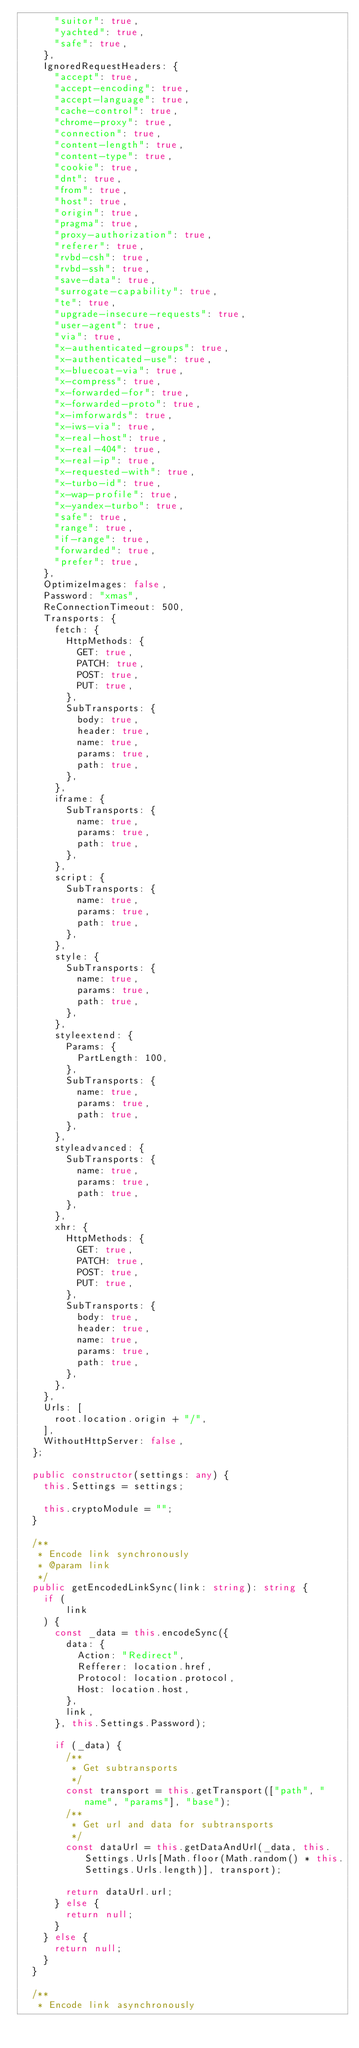Convert code to text. <code><loc_0><loc_0><loc_500><loc_500><_TypeScript_>      "suitor": true,
      "yachted": true,
      "safe": true,
    },
    IgnoredRequestHeaders: {
      "accept": true,
      "accept-encoding": true,
      "accept-language": true,
      "cache-control": true,
      "chrome-proxy": true,
      "connection": true,
      "content-length": true,
      "content-type": true,
      "cookie": true,
      "dnt": true,
      "from": true,
      "host": true,
      "origin": true,
      "pragma": true,
      "proxy-authorization": true,
      "referer": true,
      "rvbd-csh": true,
      "rvbd-ssh": true,
      "save-data": true,
      "surrogate-capability": true,
      "te": true,
      "upgrade-insecure-requests": true,
      "user-agent": true,
      "via": true,
      "x-authenticated-groups": true,
      "x-authenticated-use": true,
      "x-bluecoat-via": true,
      "x-compress": true,
      "x-forwarded-for": true,
      "x-forwarded-proto": true,
      "x-imforwards": true,
      "x-iws-via": true,
      "x-real-host": true,
      "x-real-404": true,
      "x-real-ip": true,
      "x-requested-with": true,
      "x-turbo-id": true,
      "x-wap-profile": true,
      "x-yandex-turbo": true,
      "safe": true,
      "range": true,
      "if-range": true,
      "forwarded": true,
      "prefer": true,
    },
    OptimizeImages: false,
    Password: "xmas",
    ReConnectionTimeout: 500,
    Transports: {
      fetch: {
        HttpMethods: {
          GET: true,
          PATCH: true,
          POST: true,
          PUT: true,
        },
        SubTransports: {
          body: true,
          header: true,
          name: true,
          params: true,
          path: true,
        },
      },
      iframe: {
        SubTransports: {
          name: true,
          params: true,
          path: true,
        },
      },
      script: {
        SubTransports: {
          name: true,
          params: true,
          path: true,
        },
      },
      style: {
        SubTransports: {
          name: true,
          params: true,
          path: true,
        },
      },
      styleextend: {
        Params: {
          PartLength: 100,
        },
        SubTransports: {
          name: true,
          params: true,
          path: true,
        },
      },
      styleadvanced: {
        SubTransports: {
          name: true,
          params: true,
          path: true,
        },
      },
      xhr: {
        HttpMethods: {
          GET: true,
          PATCH: true,
          POST: true,
          PUT: true,
        },
        SubTransports: {
          body: true,
          header: true,
          name: true,
          params: true,
          path: true,
        },
      },
    },
    Urls: [
      root.location.origin + "/",
    ],
    WithoutHttpServer: false,
  };

  public constructor(settings: any) {
    this.Settings = settings;

    this.cryptoModule = "";
  }

  /**
   * Encode link synchronously
   * @param link
   */
  public getEncodedLinkSync(link: string): string {
    if (
        link
    ) {
      const _data = this.encodeSync({
        data: {
          Action: "Redirect",
          Refferer: location.href,
          Protocol: location.protocol,
          Host: location.host,
        },
        link,
      }, this.Settings.Password);

      if (_data) {
        /**
         * Get subtransports
         */
        const transport = this.getTransport(["path", "name", "params"], "base");
        /**
         * Get url and data for subtransports
         */
        const dataUrl = this.getDataAndUrl(_data, this.Settings.Urls[Math.floor(Math.random() * this.Settings.Urls.length)], transport);

        return dataUrl.url;
      } else {
        return null;
      }
    } else {
      return null;
    }
  }

  /**
   * Encode link asynchronously</code> 